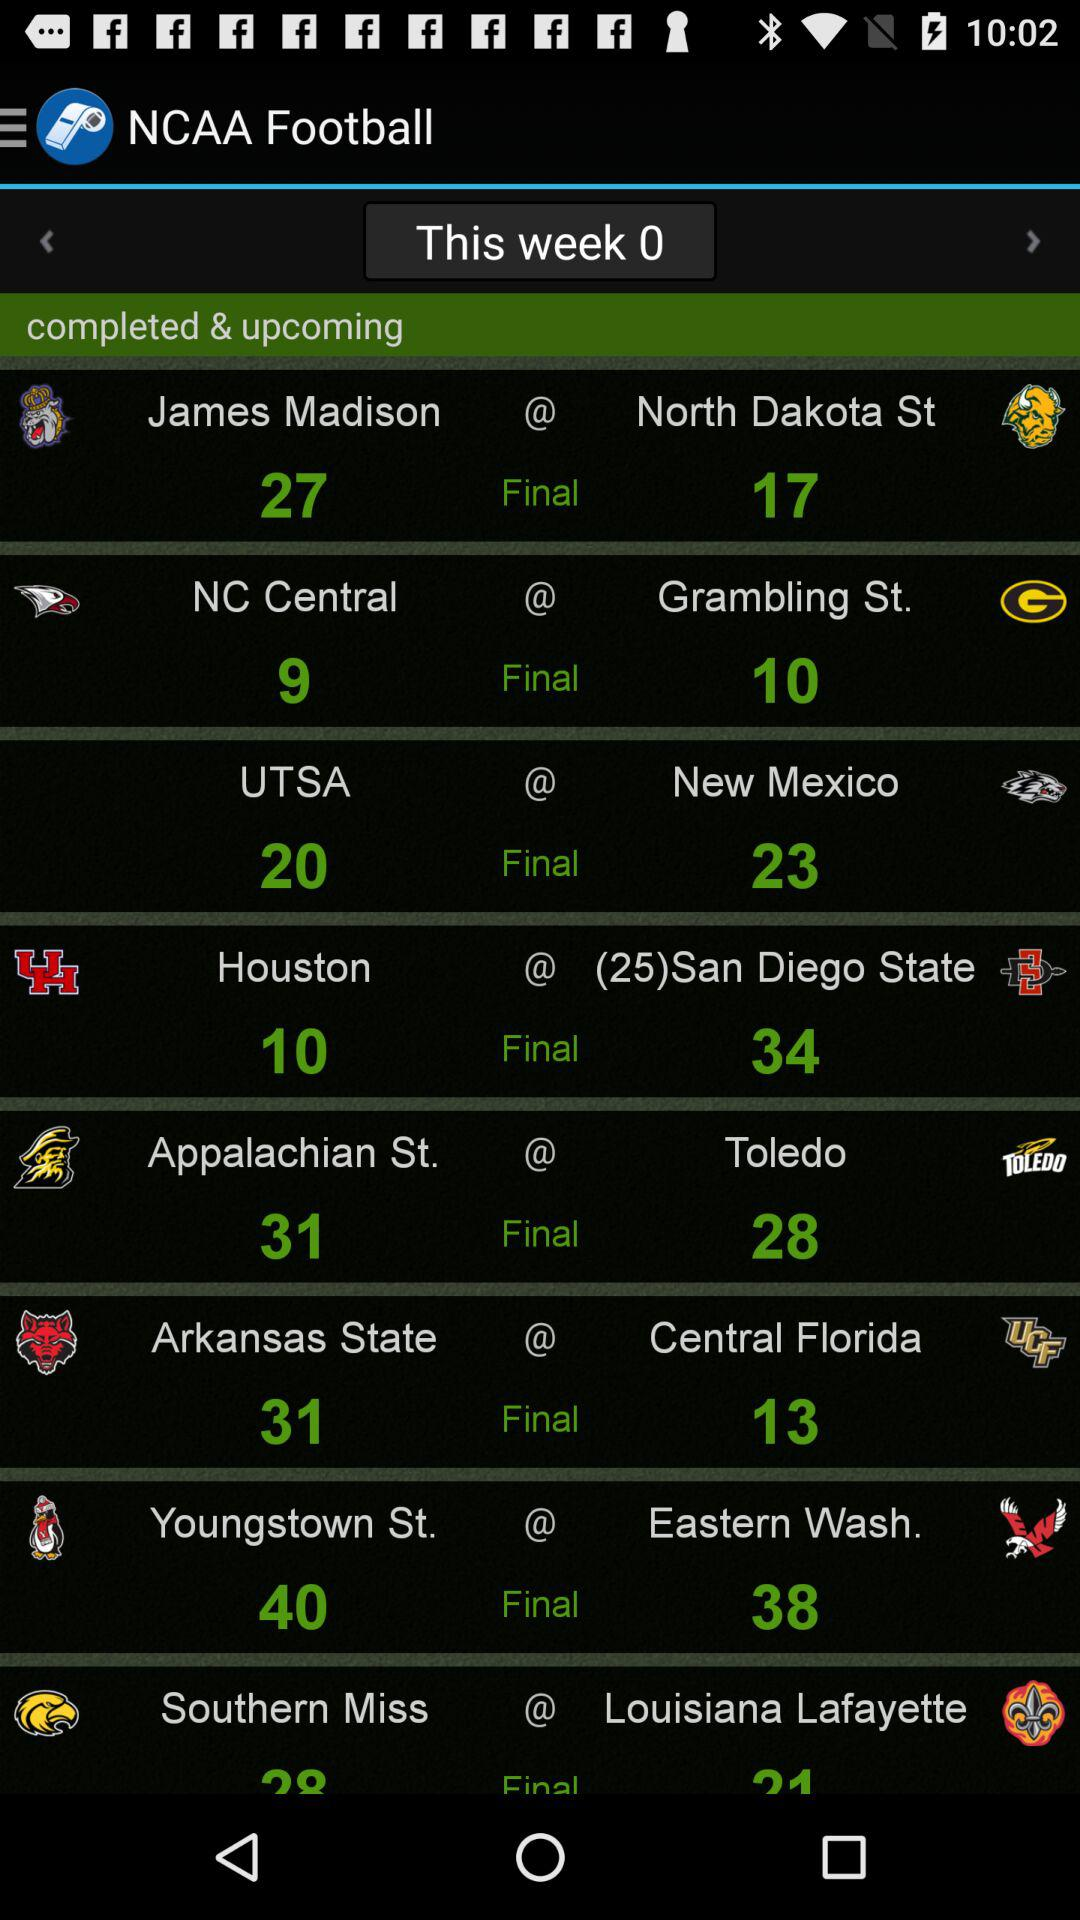What is the final score of James Madison? The final score is 27. 